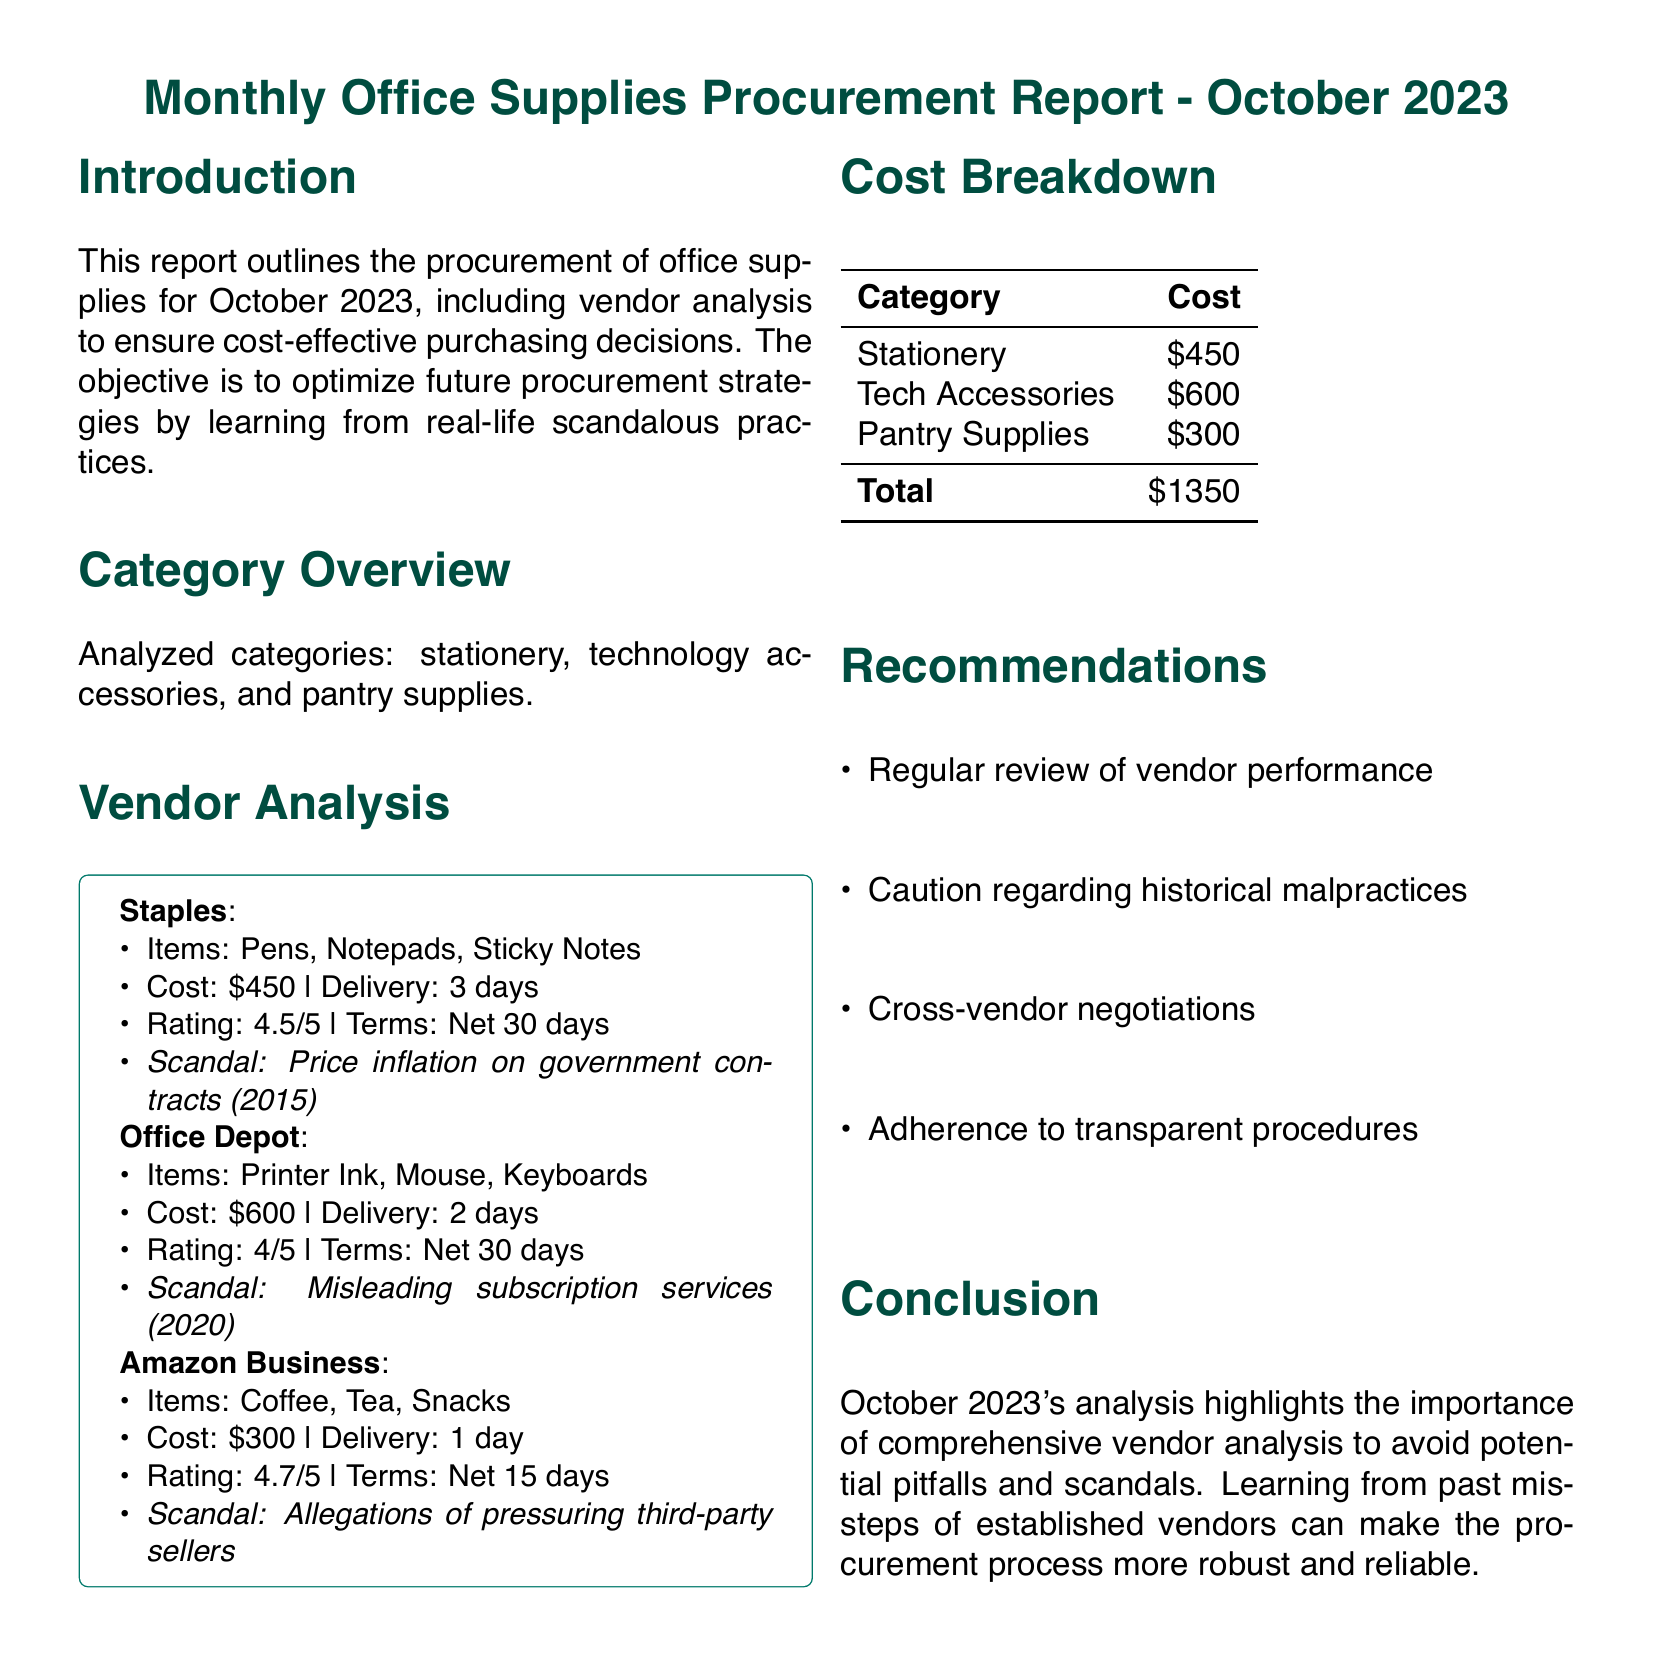What is the total cost of office supplies? The total cost is provided in the cost breakdown section, summarizing all categories.
Answer: $1350 What items did Staples provide? The items from Staples are listed under the vendor analysis section.
Answer: Pens, Notepads, Sticky Notes What rating did Amazon Business receive? The rating for Amazon Business is shown as part of the vendor analysis.
Answer: 4.7/5 What was the delivery time for Office Depot? The delivery time of Office Depot is detailed in the vendor analysis section.
Answer: 2 days What scandal is associated with Staples? The specific scandal associated with Staples is highlighted in the vendor analysis.
Answer: Price inflation on government contracts (2015) Which vendor offered pantry supplies? The vendor providing pantry supplies is mentioned in the vendor analysis.
Answer: Amazon Business What is the payment terms for Amazon Business? The payment terms for Amazon Business are outlined in the vendor analysis.
Answer: Net 15 days What recommendations were made in the report? Recommendations are listed at the end of the report for procurement strategy optimization.
Answer: Regular review of vendor performance How many categories were analyzed in the report? The number of categories is mentioned in the category overview section.
Answer: Three 